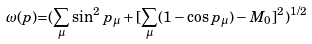<formula> <loc_0><loc_0><loc_500><loc_500>\omega ( p ) { = } ( \sum _ { \mu } \sin ^ { 2 } p _ { \mu } + [ \sum _ { \mu } ( 1 - \cos p _ { \mu } ) - M _ { 0 } ] ^ { 2 } ) ^ { 1 / 2 }</formula> 